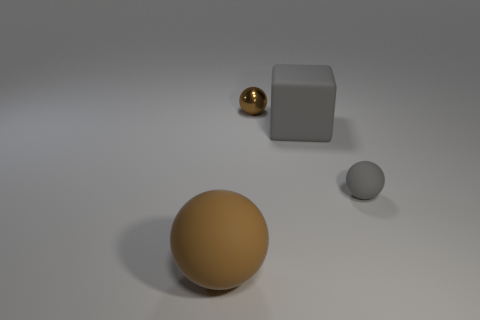There is a matte thing that is the same color as the small matte sphere; what shape is it?
Provide a succinct answer. Cube. What size is the thing that is the same color as the large rubber block?
Provide a succinct answer. Small. Do the block and the brown metallic sphere have the same size?
Offer a terse response. No. What number of cylinders are either gray matte things or green metal objects?
Provide a succinct answer. 0. What number of tiny brown metallic things are in front of the large object right of the tiny metal thing?
Offer a very short reply. 0. Is the big brown thing the same shape as the small brown shiny thing?
Offer a terse response. Yes. There is another brown thing that is the same shape as the brown metallic thing; what size is it?
Your response must be concise. Large. There is a brown object that is to the left of the tiny brown object behind the small rubber sphere; what is its shape?
Your answer should be compact. Sphere. What is the size of the brown rubber ball?
Your response must be concise. Large. The large gray rubber thing is what shape?
Provide a short and direct response. Cube. 